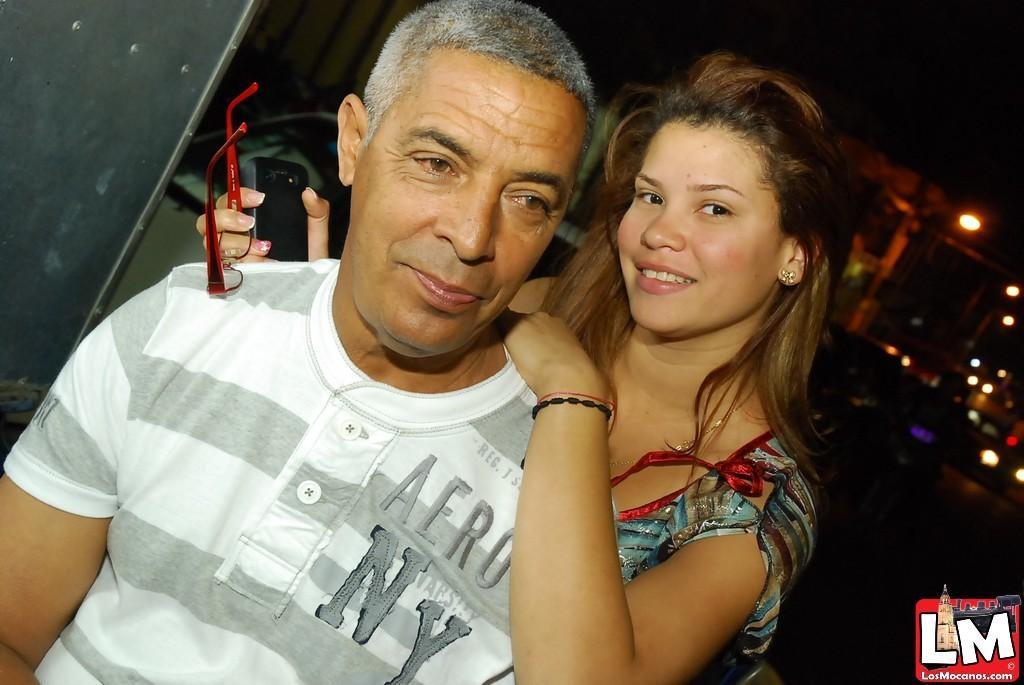Please provide a concise description of this image. In the image there is a girl standing behind an old man in white t-shirt and in the background there are lights. 